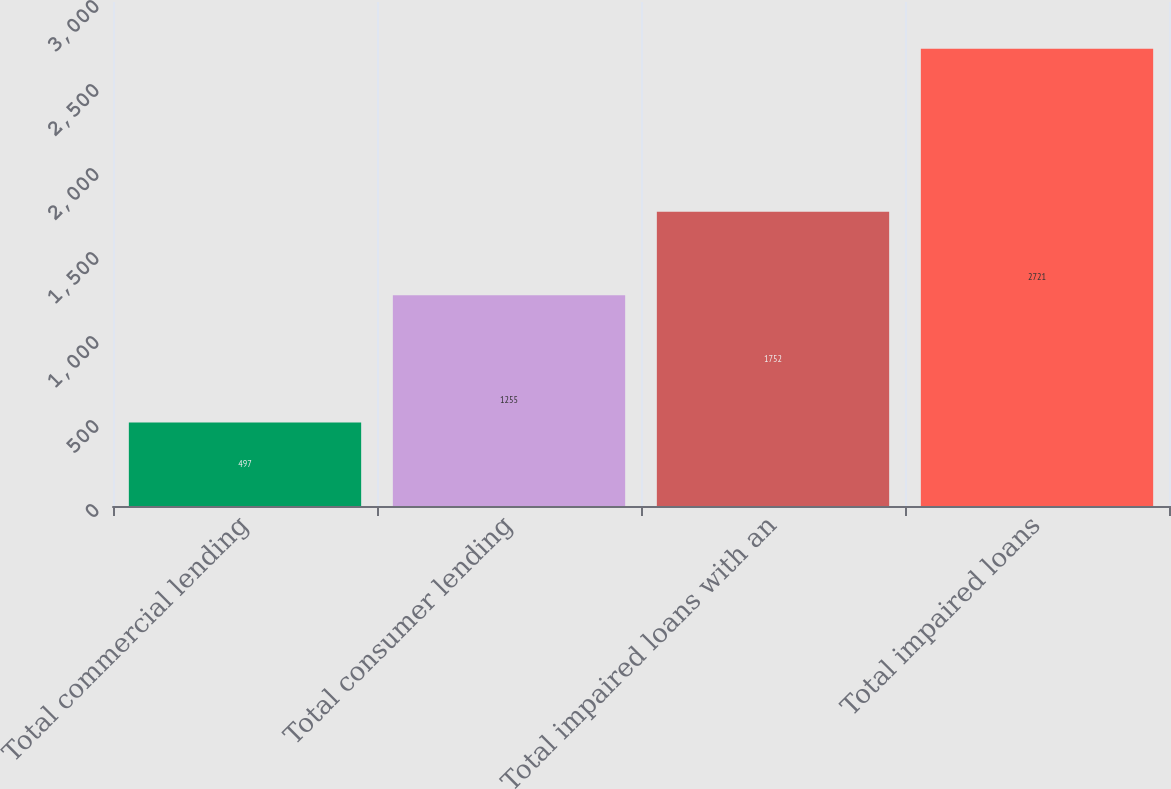Convert chart to OTSL. <chart><loc_0><loc_0><loc_500><loc_500><bar_chart><fcel>Total commercial lending<fcel>Total consumer lending<fcel>Total impaired loans with an<fcel>Total impaired loans<nl><fcel>497<fcel>1255<fcel>1752<fcel>2721<nl></chart> 